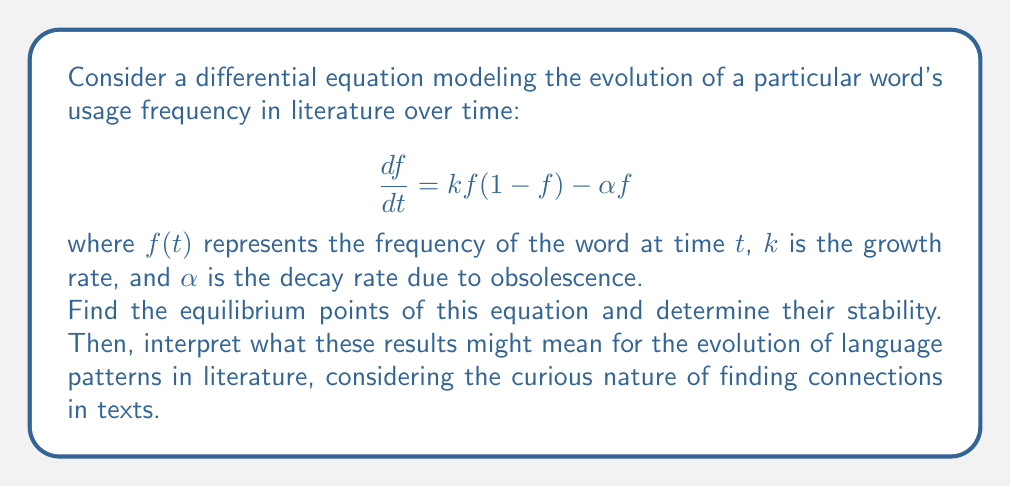Solve this math problem. Let's approach this step-by-step:

1) To find the equilibrium points, we set $\frac{df}{dt} = 0$:

   $$kf(1-f) - \alpha f = 0$$

2) Factor out $f$:

   $$f(k(1-f) - \alpha) = 0$$

3) Solve for $f$:
   
   Either $f = 0$, or $k(1-f) - \alpha = 0$

4) From the second equation:
   
   $$k - kf - \alpha = 0$$
   $$kf = k - \alpha$$
   $$f = 1 - \frac{\alpha}{k}$$

5) Therefore, the equilibrium points are:

   $$f_1 = 0 \text{ and } f_2 = 1 - \frac{\alpha}{k}$$

6) To determine stability, we evaluate the derivative of $\frac{df}{dt}$ with respect to $f$ at each equilibrium point:

   $$\frac{d}{df}(\frac{df}{dt}) = k(1-2f) - \alpha$$

7) At $f_1 = 0$:
   
   $$k - \alpha$$

   If $k > \alpha$, this is positive, and $f_1$ is unstable.
   If $k < \alpha$, this is negative, and $f_1$ is stable.

8) At $f_2 = 1 - \frac{\alpha}{k}$:

   $$k(1-2(1-\frac{\alpha}{k})) - \alpha = -k + 2\alpha - \alpha = \alpha - k$$

   This is always negative (assuming $k > \alpha$), so $f_2$ is stable.

Interpretation: The equilibrium point $f_1 = 0$ represents the word falling out of use completely. This is stable if the decay rate ($\alpha$) exceeds the growth rate ($k$), meaning the word is likely to become obsolete. The second equilibrium point $f_2 = 1 - \frac{\alpha}{k}$ represents a stable usage frequency, where the word's growth and decay balance each other. This model suggests that words in literature tend towards either extinction or a stable usage rate, depending on the relative strengths of their growth and decay factors.
Answer: Equilibrium points: $f_1 = 0$ and $f_2 = 1 - \frac{\alpha}{k}$

Stability:
$f_1$ is stable if $k < \alpha$, unstable if $k > \alpha$
$f_2$ is stable when it exists ($k > \alpha$) 